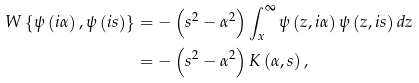Convert formula to latex. <formula><loc_0><loc_0><loc_500><loc_500>W \left \{ \psi \left ( i \alpha \right ) , \psi \left ( i s \right ) \right \} & = - \left ( s ^ { 2 } - \alpha ^ { 2 } \right ) \int _ { x } ^ { \infty } \psi \left ( z , i \alpha \right ) \psi \left ( z , i s \right ) d z \\ & = - \left ( s ^ { 2 } - \alpha ^ { 2 } \right ) K \left ( \alpha , s \right ) ,</formula> 